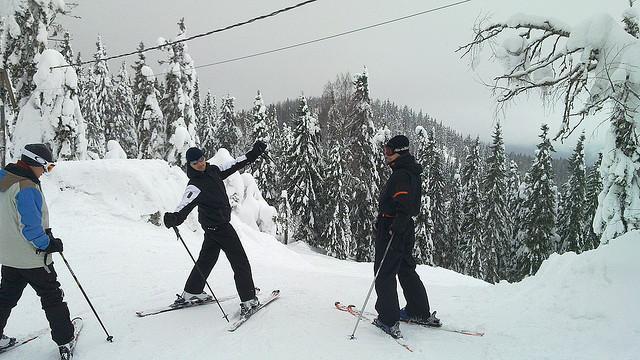How many guys are skiing?
Give a very brief answer. 3. How many people are there?
Give a very brief answer. 3. 